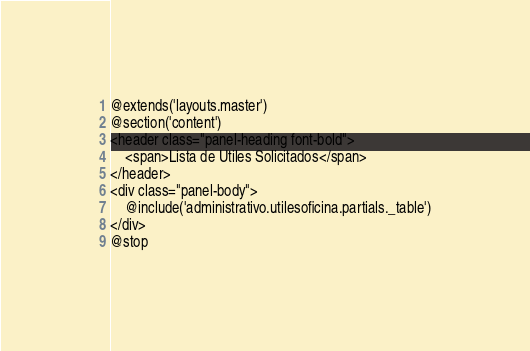Convert code to text. <code><loc_0><loc_0><loc_500><loc_500><_PHP_>@extends('layouts.master')
@section('content')
<header class="panel-heading font-bold">
    <span>Lista de Utiles Solicitados</span>
</header>
<div class="panel-body">
    @include('administrativo.utilesoficina.partials._table')
</div>
@stop</code> 